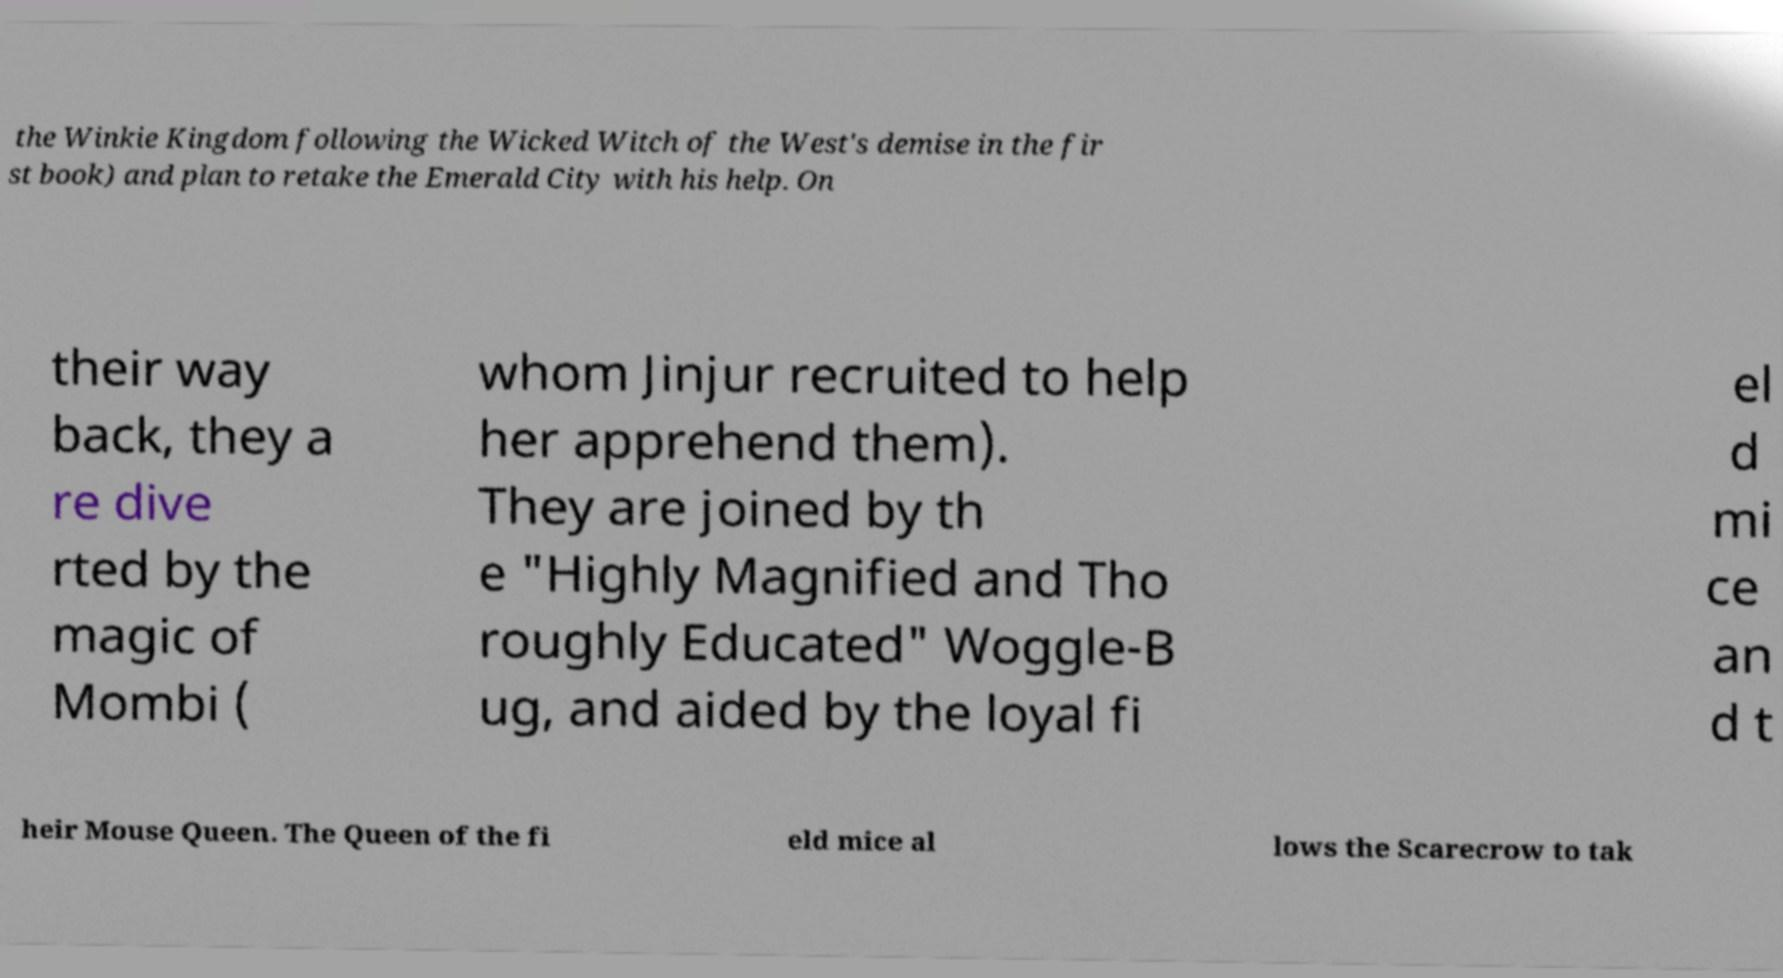Could you extract and type out the text from this image? the Winkie Kingdom following the Wicked Witch of the West's demise in the fir st book) and plan to retake the Emerald City with his help. On their way back, they a re dive rted by the magic of Mombi ( whom Jinjur recruited to help her apprehend them). They are joined by th e "Highly Magnified and Tho roughly Educated" Woggle-B ug, and aided by the loyal fi el d mi ce an d t heir Mouse Queen. The Queen of the fi eld mice al lows the Scarecrow to tak 